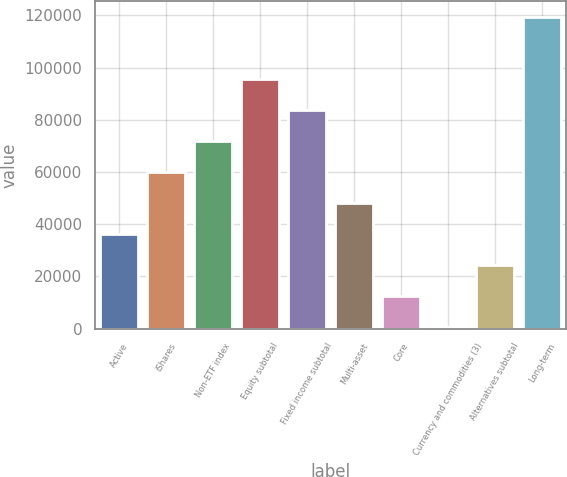<chart> <loc_0><loc_0><loc_500><loc_500><bar_chart><fcel>Active<fcel>iShares<fcel>Non-ETF index<fcel>Equity subtotal<fcel>Fixed income subtotal<fcel>Multi-asset<fcel>Core<fcel>Currency and commodities (3)<fcel>Alternatives subtotal<fcel>Long-term<nl><fcel>36360.3<fcel>60108.5<fcel>71982.6<fcel>95730.8<fcel>83856.7<fcel>48234.4<fcel>12612.1<fcel>738<fcel>24486.2<fcel>119479<nl></chart> 